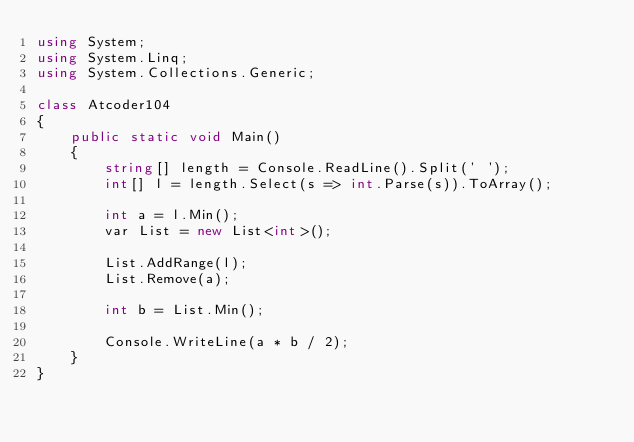Convert code to text. <code><loc_0><loc_0><loc_500><loc_500><_C#_>using System;
using System.Linq;
using System.Collections.Generic;

class Atcoder104
{
    public static void Main()
    {
        string[] length = Console.ReadLine().Split(' ');
        int[] l = length.Select(s => int.Parse(s)).ToArray();

        int a = l.Min();
        var List = new List<int>();

        List.AddRange(l);
        List.Remove(a);

        int b = List.Min();

        Console.WriteLine(a * b / 2);
    }
}</code> 